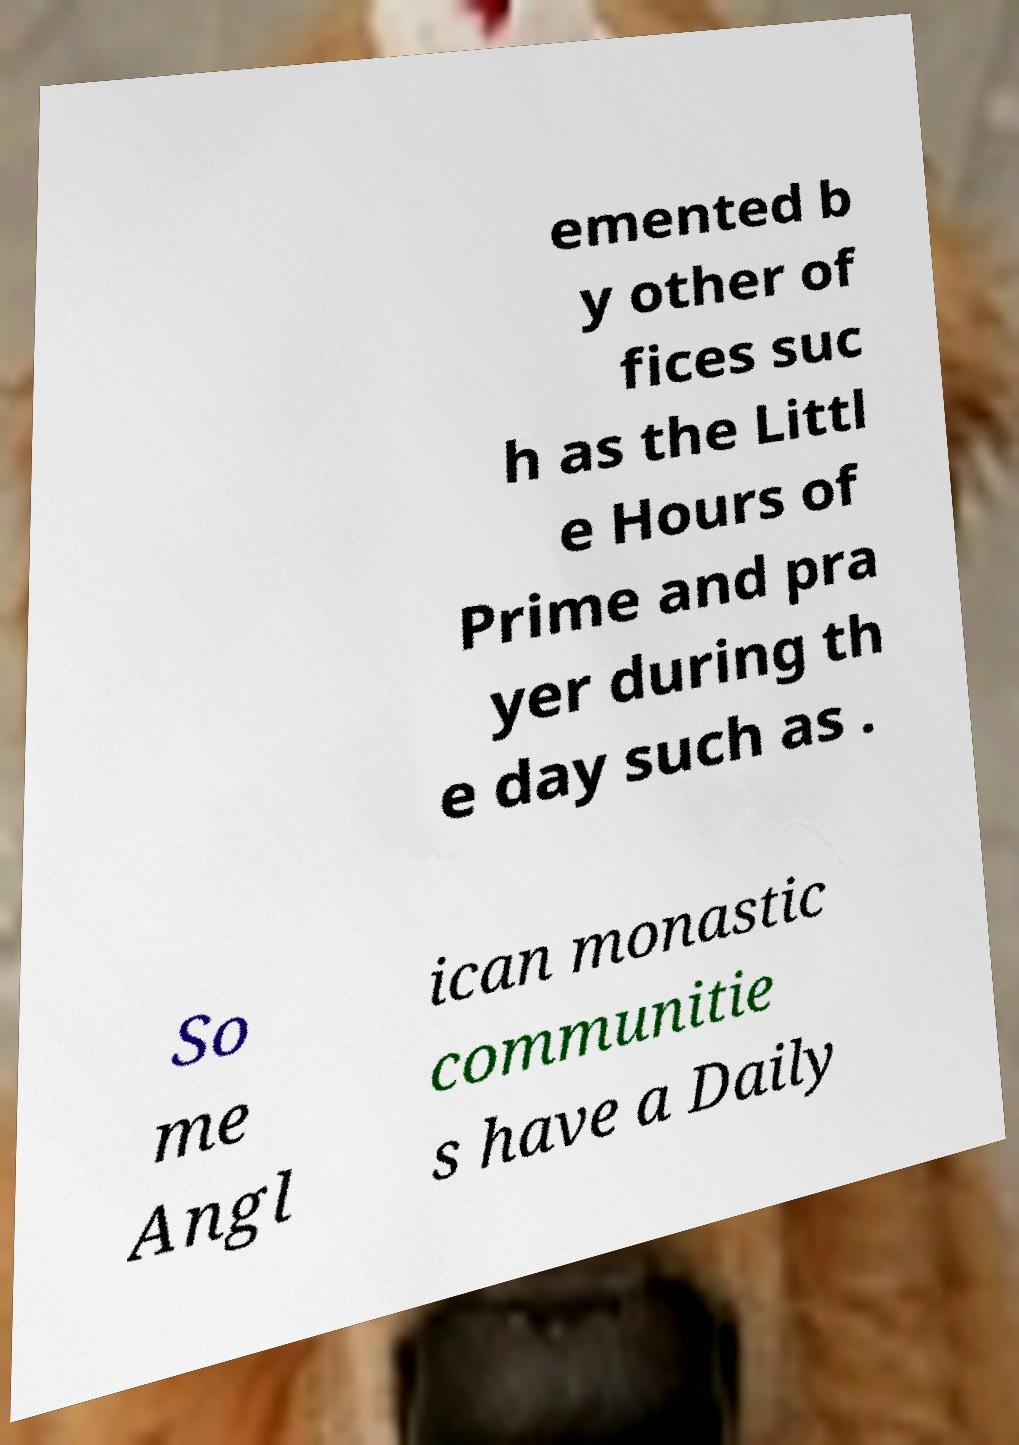Can you read and provide the text displayed in the image?This photo seems to have some interesting text. Can you extract and type it out for me? emented b y other of fices suc h as the Littl e Hours of Prime and pra yer during th e day such as . So me Angl ican monastic communitie s have a Daily 